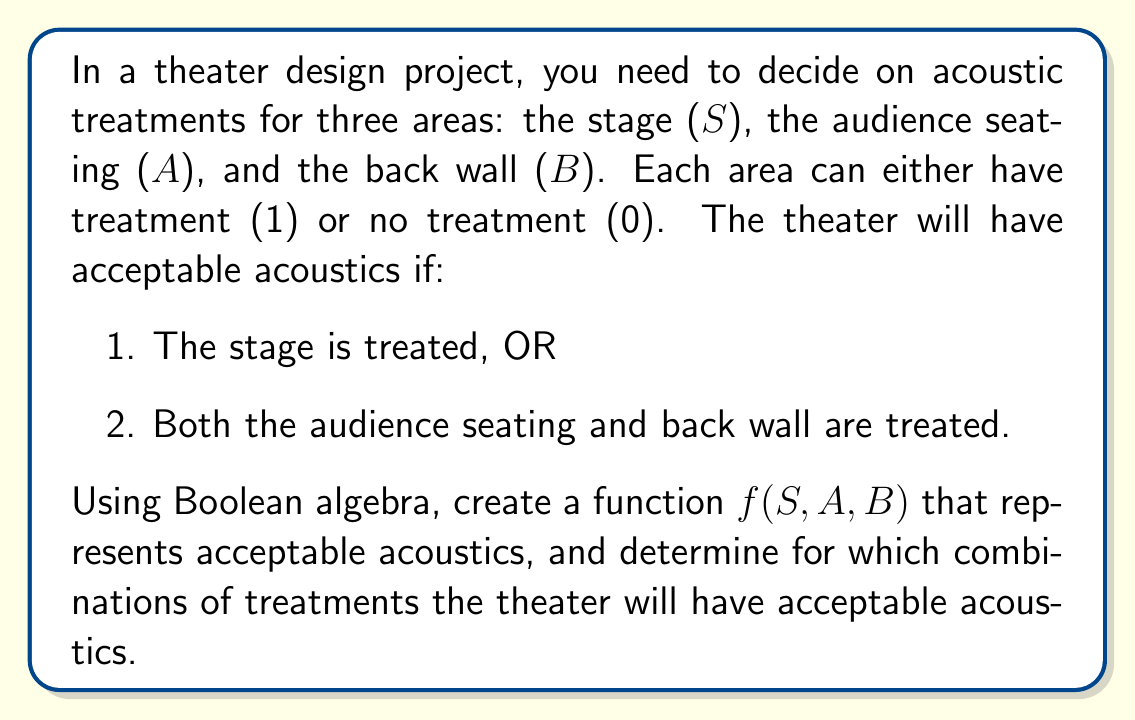Show me your answer to this math problem. Let's approach this step-by-step:

1) First, we need to translate the given conditions into Boolean algebra:
   - Condition 1: S
   - Condition 2: A AND B

2) The theater has acceptable acoustics if either of these conditions is true. In Boolean algebra, OR is represented by the + symbol. So our function becomes:

   $f(S,A,B) = S + (A \cdot B)$

3) Now, we need to evaluate this function for all possible combinations of S, A, and B. There are 8 possible combinations:

   $$\begin{array}{|c|c|c|c|}
   \hline
   S & A & B & f(S,A,B) \\
   \hline
   0 & 0 & 0 & 0 \\
   0 & 0 & 1 & 0 \\
   0 & 1 & 0 & 0 \\
   0 & 1 & 1 & 1 \\
   1 & 0 & 0 & 1 \\
   1 & 0 & 1 & 1 \\
   1 & 1 & 0 & 1 \\
   1 & 1 & 1 & 1 \\
   \hline
   \end{array}$$

4) From this truth table, we can see that the theater will have acceptable acoustics (f(S,A,B) = 1) in the following cases:
   - When S = 1 (regardless of A and B)
   - When A = 1 AND B = 1 (even if S = 0)

5) We can express this in Boolean algebra as:

   $f(S,A,B) = S + (A \cdot B) = 1$

   This equation is satisfied when S = 1 OR (A = 1 AND B = 1).
Answer: $f(S,A,B) = S + (A \cdot B) = 1$ when S = 1 OR (A = 1 AND B = 1) 